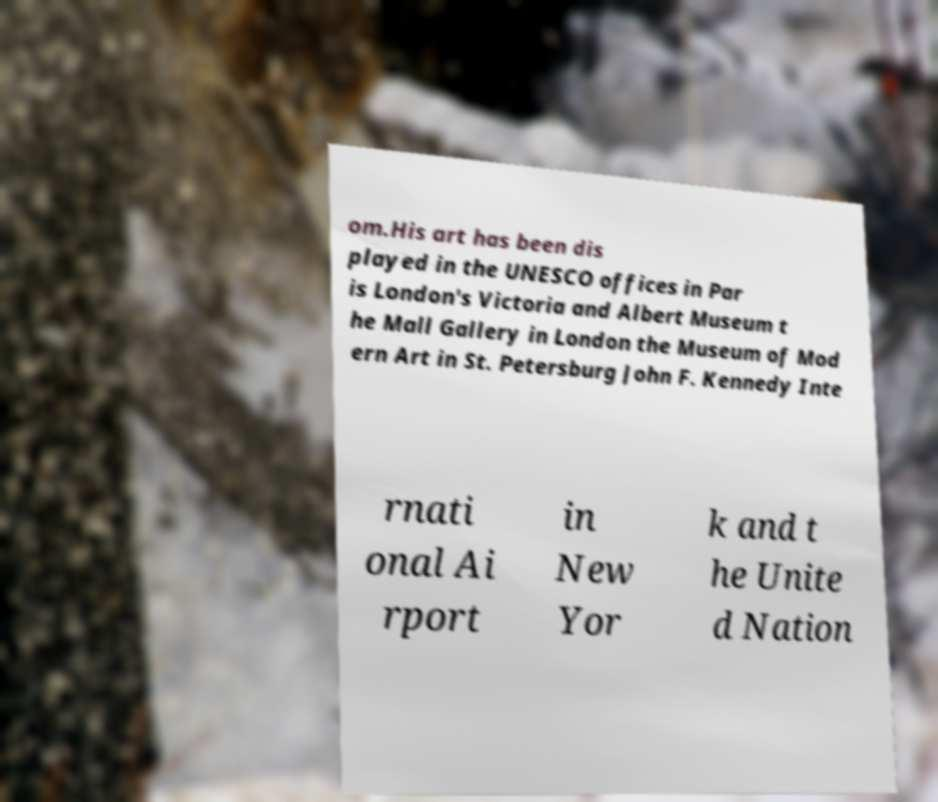What messages or text are displayed in this image? I need them in a readable, typed format. om.His art has been dis played in the UNESCO offices in Par is London's Victoria and Albert Museum t he Mall Gallery in London the Museum of Mod ern Art in St. Petersburg John F. Kennedy Inte rnati onal Ai rport in New Yor k and t he Unite d Nation 